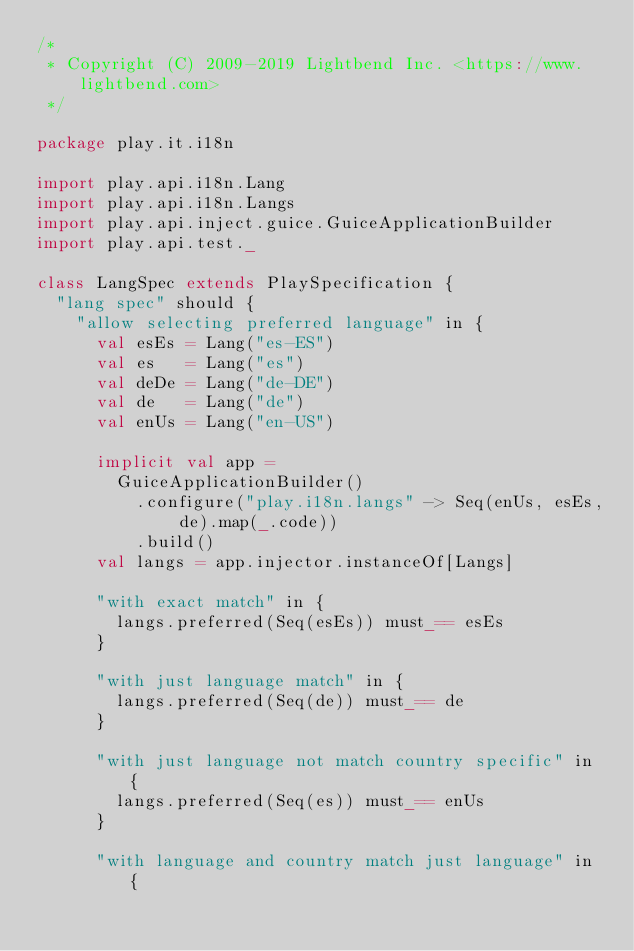<code> <loc_0><loc_0><loc_500><loc_500><_Scala_>/*
 * Copyright (C) 2009-2019 Lightbend Inc. <https://www.lightbend.com>
 */

package play.it.i18n

import play.api.i18n.Lang
import play.api.i18n.Langs
import play.api.inject.guice.GuiceApplicationBuilder
import play.api.test._

class LangSpec extends PlaySpecification {
  "lang spec" should {
    "allow selecting preferred language" in {
      val esEs = Lang("es-ES")
      val es   = Lang("es")
      val deDe = Lang("de-DE")
      val de   = Lang("de")
      val enUs = Lang("en-US")

      implicit val app =
        GuiceApplicationBuilder()
          .configure("play.i18n.langs" -> Seq(enUs, esEs, de).map(_.code))
          .build()
      val langs = app.injector.instanceOf[Langs]

      "with exact match" in {
        langs.preferred(Seq(esEs)) must_== esEs
      }

      "with just language match" in {
        langs.preferred(Seq(de)) must_== de
      }

      "with just language not match country specific" in {
        langs.preferred(Seq(es)) must_== enUs
      }

      "with language and country match just language" in {</code> 